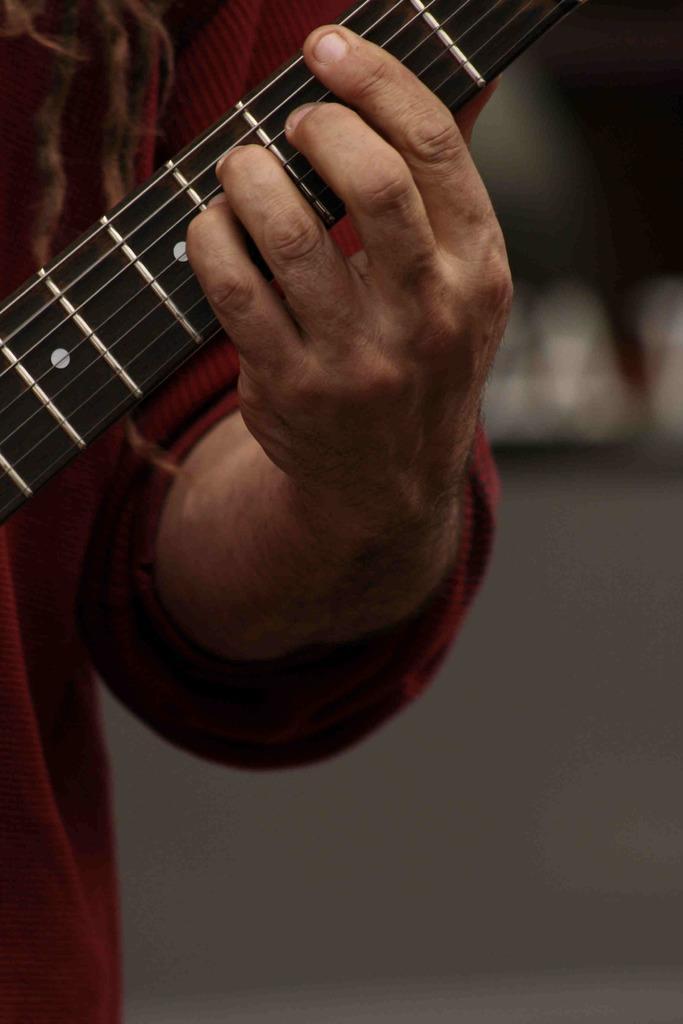Can you describe this image briefly? The image consist of a person, he is holding a guitar, his fingers are placed on the strings of the guitar. 